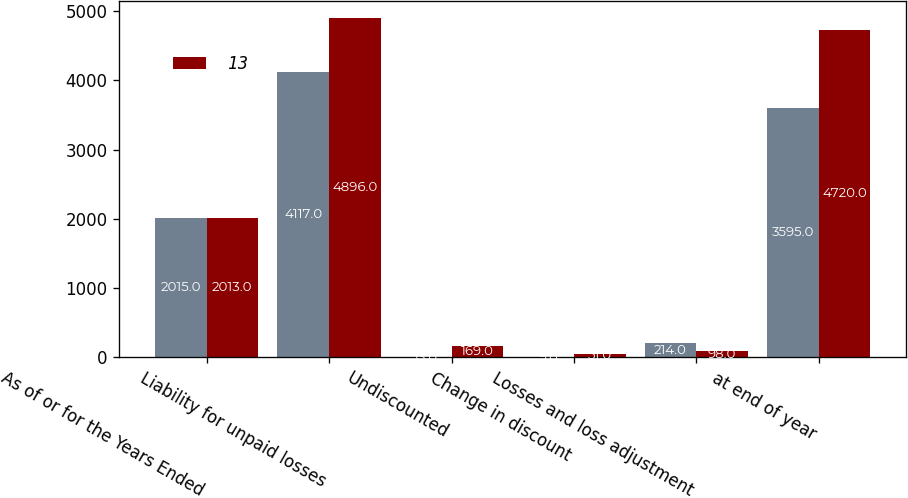<chart> <loc_0><loc_0><loc_500><loc_500><stacked_bar_chart><ecel><fcel>As of or for the Years Ended<fcel>Liability for unpaid losses<fcel>Undiscounted<fcel>Change in discount<fcel>Losses and loss adjustment<fcel>at end of year<nl><fcel>nan<fcel>2015<fcel>4117<fcel>13<fcel>9<fcel>214<fcel>3595<nl><fcel>13<fcel>2013<fcel>4896<fcel>169<fcel>51<fcel>98<fcel>4720<nl></chart> 